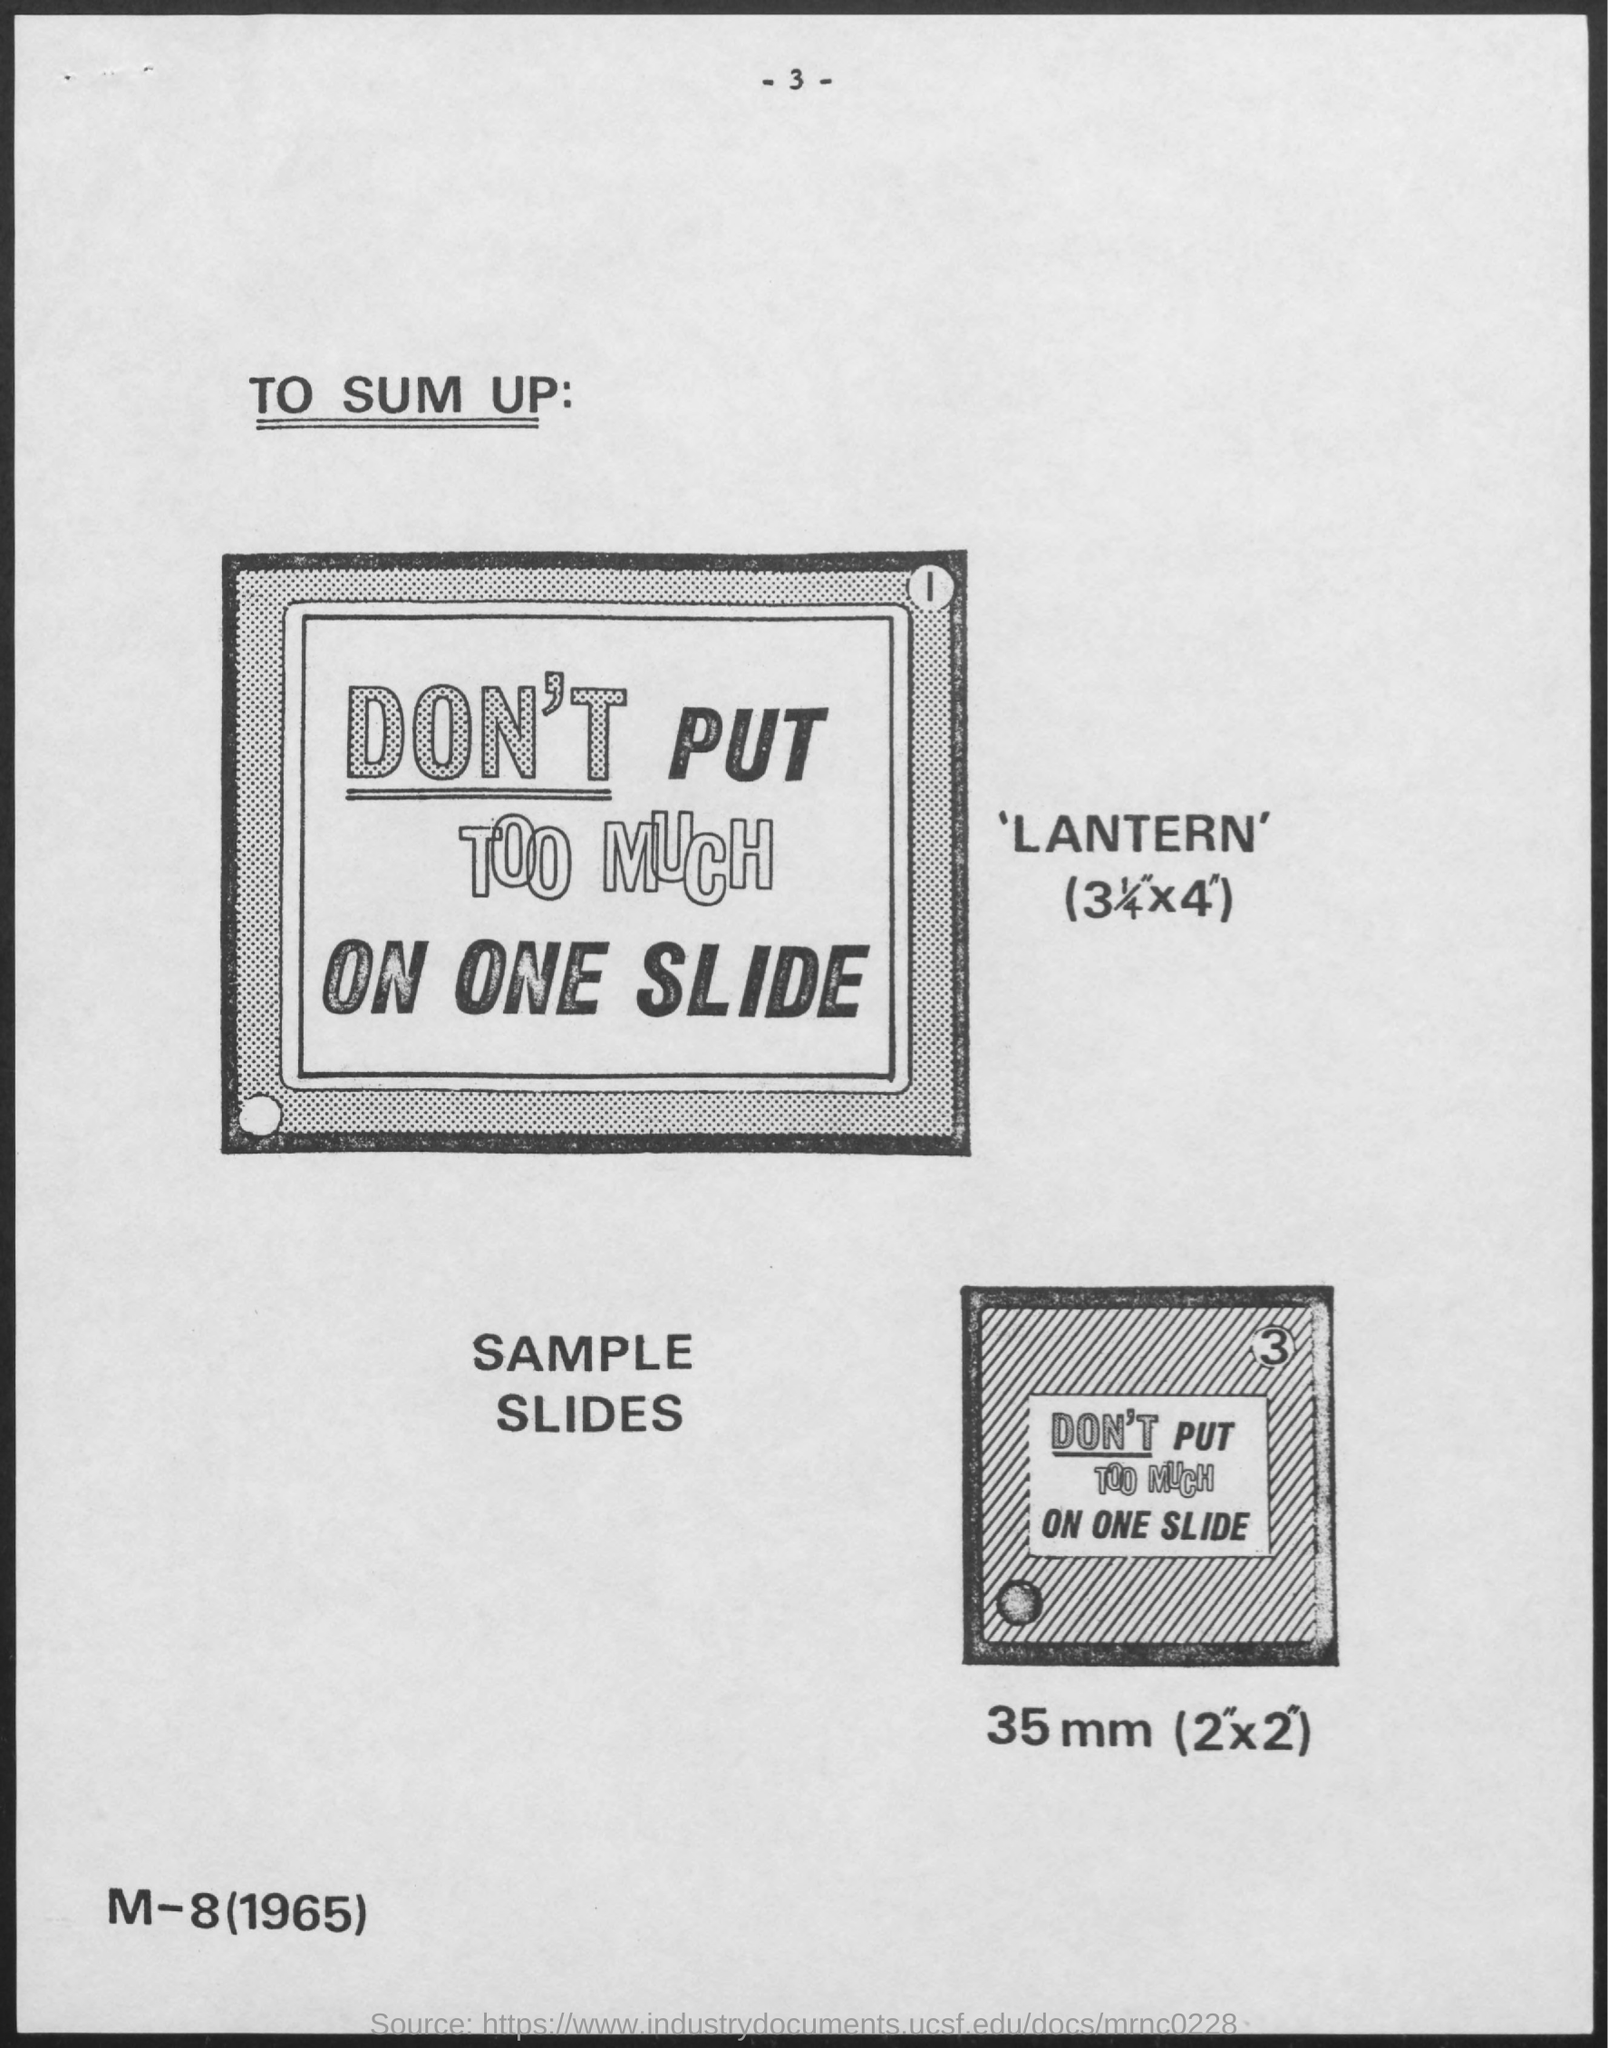Mention a couple of crucial points in this snapshot. The length of one side of the second box, which has a bottom measurement of 35 mm and is 2 inches by 2 inches, is... What is the page number? It is 3... What is the first title in the document? To Sum Up: 